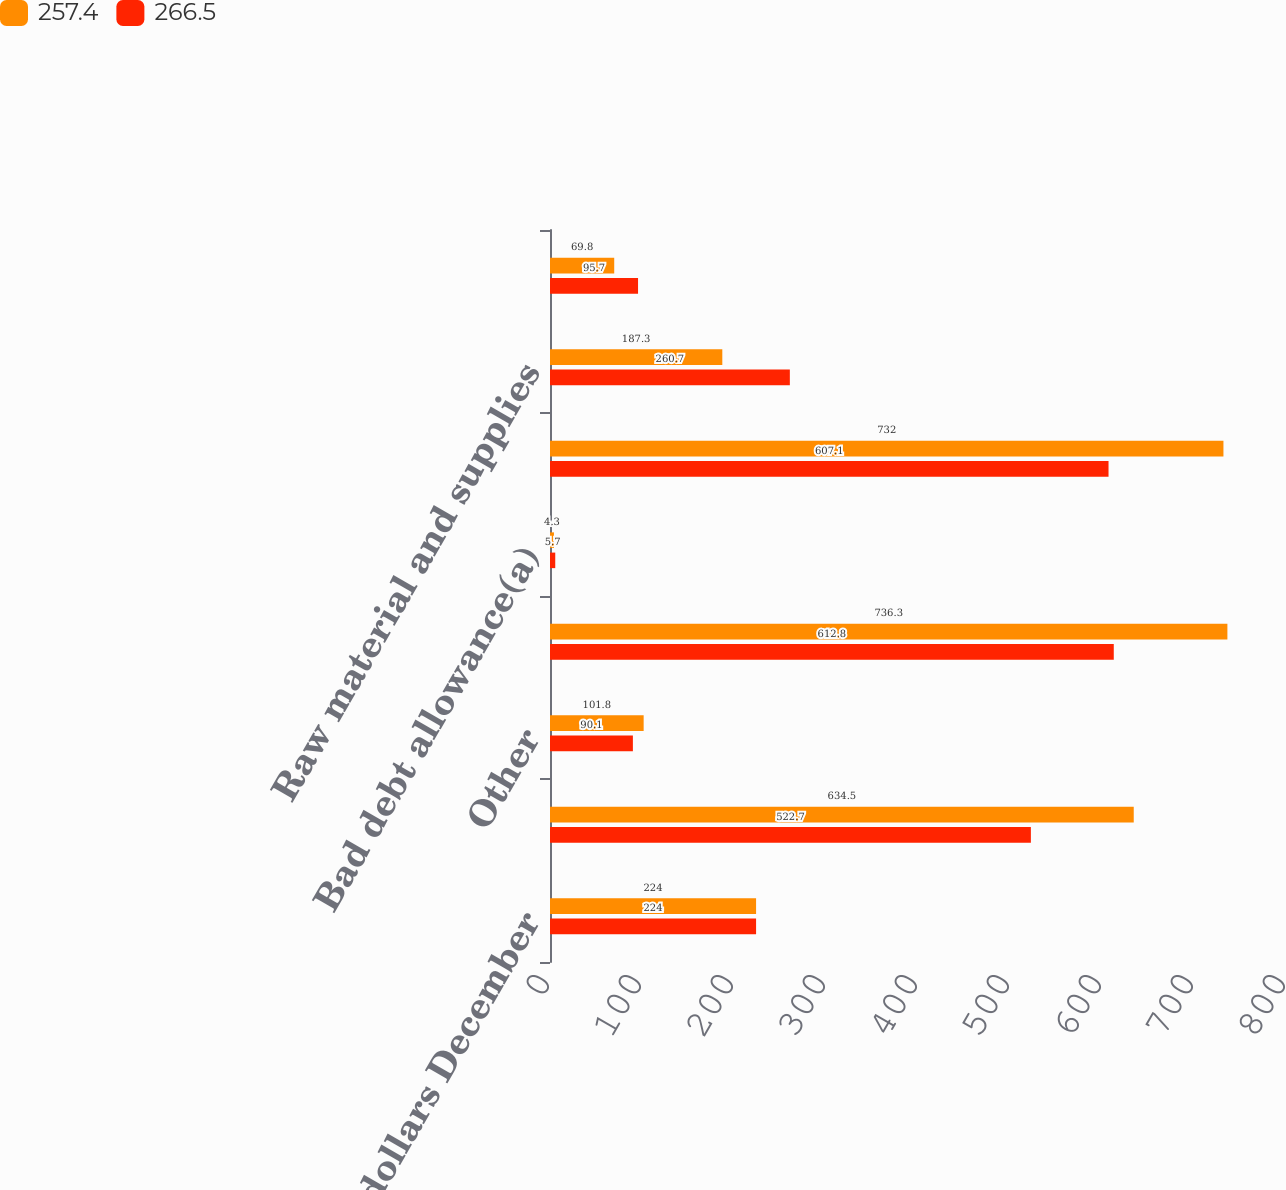Convert chart to OTSL. <chart><loc_0><loc_0><loc_500><loc_500><stacked_bar_chart><ecel><fcel>millions of dollars December<fcel>Customers<fcel>Other<fcel>Gross receivables<fcel>Bad debt allowance(a)<fcel>Net receivables<fcel>Raw material and supplies<fcel>Work in progress<nl><fcel>257.4<fcel>224<fcel>634.5<fcel>101.8<fcel>736.3<fcel>4.3<fcel>732<fcel>187.3<fcel>69.8<nl><fcel>266.5<fcel>224<fcel>522.7<fcel>90.1<fcel>612.8<fcel>5.7<fcel>607.1<fcel>260.7<fcel>95.7<nl></chart> 